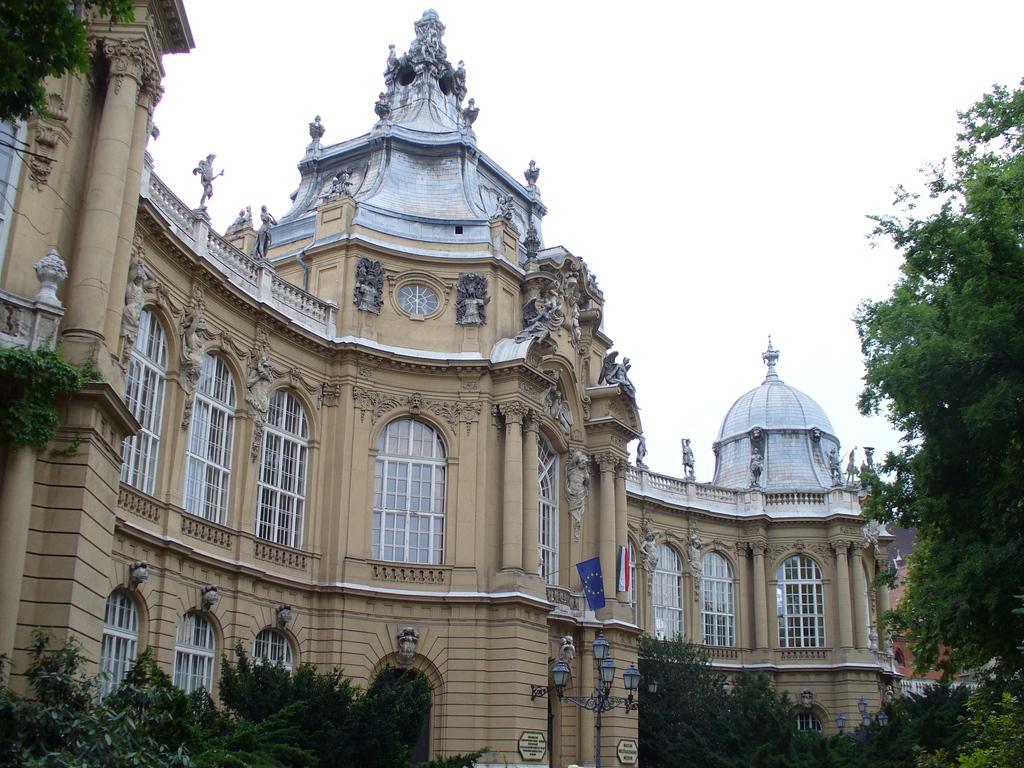Please provide a concise description of this image. In this image I can see a building which has flags on it. In the background I can see the sky. Here I can see trees. 